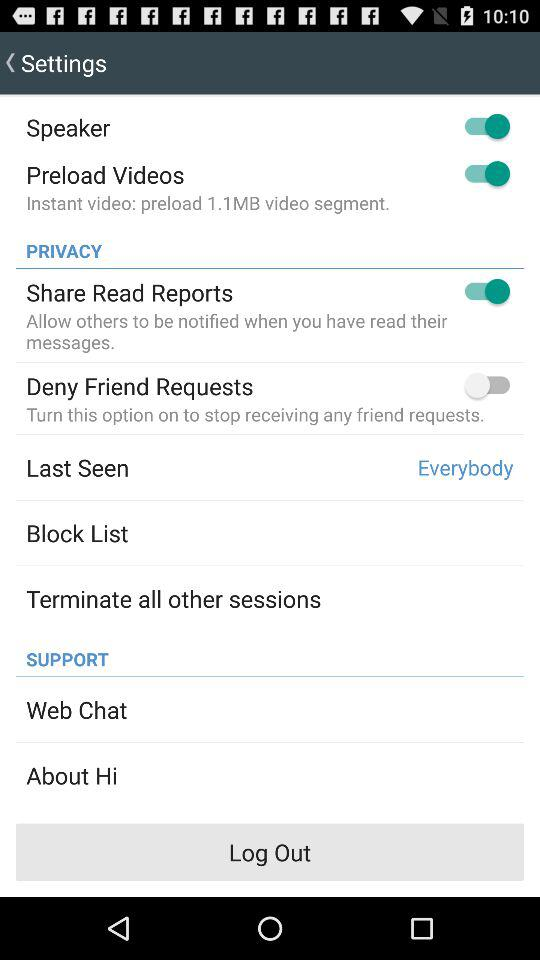What is the status of "Preload Videos"? The status is "on". 